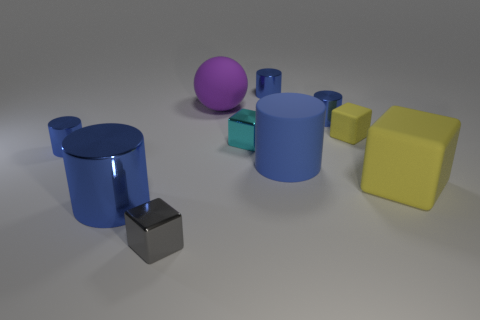What is the material of the cyan block that is the same size as the gray shiny thing?
Your answer should be very brief. Metal. Is there a tiny gray cube that has the same material as the small cyan thing?
Offer a very short reply. Yes. What is the color of the small cube that is both behind the gray shiny cube and in front of the small matte cube?
Your response must be concise. Cyan. What number of other objects are there of the same color as the ball?
Provide a succinct answer. 0. There is a small cube that is in front of the large blue cylinder that is on the right side of the shiny cube behind the small gray metal thing; what is its material?
Offer a very short reply. Metal. What number of cylinders are either yellow objects or cyan metal things?
Make the answer very short. 0. How many small cubes are in front of the object that is on the left side of the big cylinder that is left of the tiny gray thing?
Keep it short and to the point. 1. Is the shape of the tiny matte object the same as the big purple rubber object?
Keep it short and to the point. No. Does the large blue thing that is right of the small cyan cube have the same material as the big cube that is to the right of the big matte sphere?
Offer a terse response. Yes. How many things are either large blue matte cylinders to the left of the small yellow rubber object or blue shiny cylinders that are behind the blue matte cylinder?
Your response must be concise. 4. 